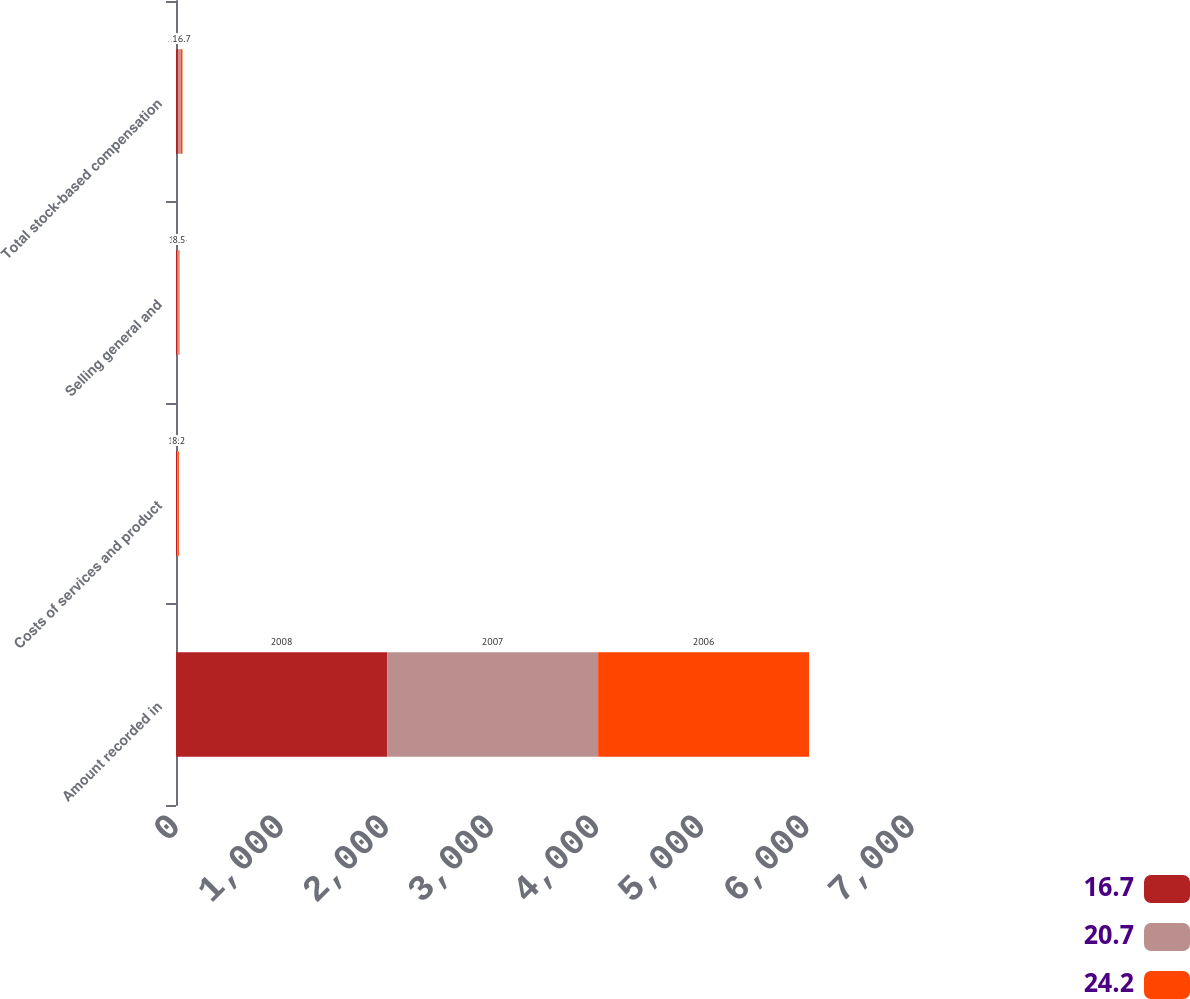<chart> <loc_0><loc_0><loc_500><loc_500><stacked_bar_chart><ecel><fcel>Amount recorded in<fcel>Costs of services and product<fcel>Selling general and<fcel>Total stock-based compensation<nl><fcel>16.7<fcel>2008<fcel>9.6<fcel>11.1<fcel>20.7<nl><fcel>20.7<fcel>2007<fcel>10.8<fcel>13.4<fcel>24.2<nl><fcel>24.2<fcel>2006<fcel>8.2<fcel>8.5<fcel>16.7<nl></chart> 